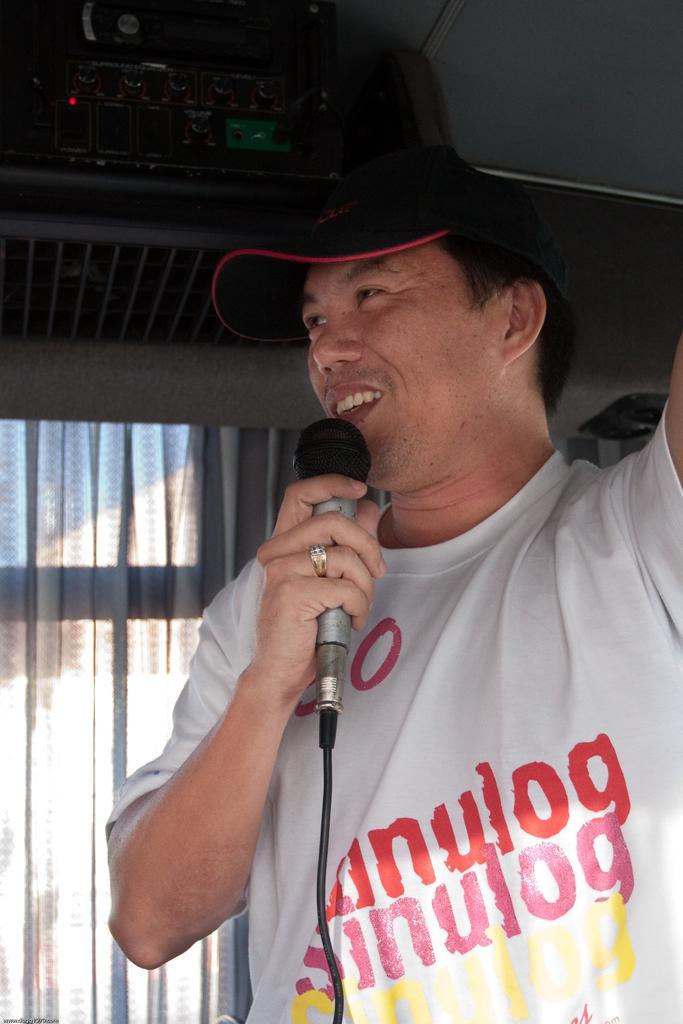How would you summarize this image in a sentence or two? Here we can see a man holding a microphone in his hand and he is speaking. Here we can see a window which is bounded with a curtain. 